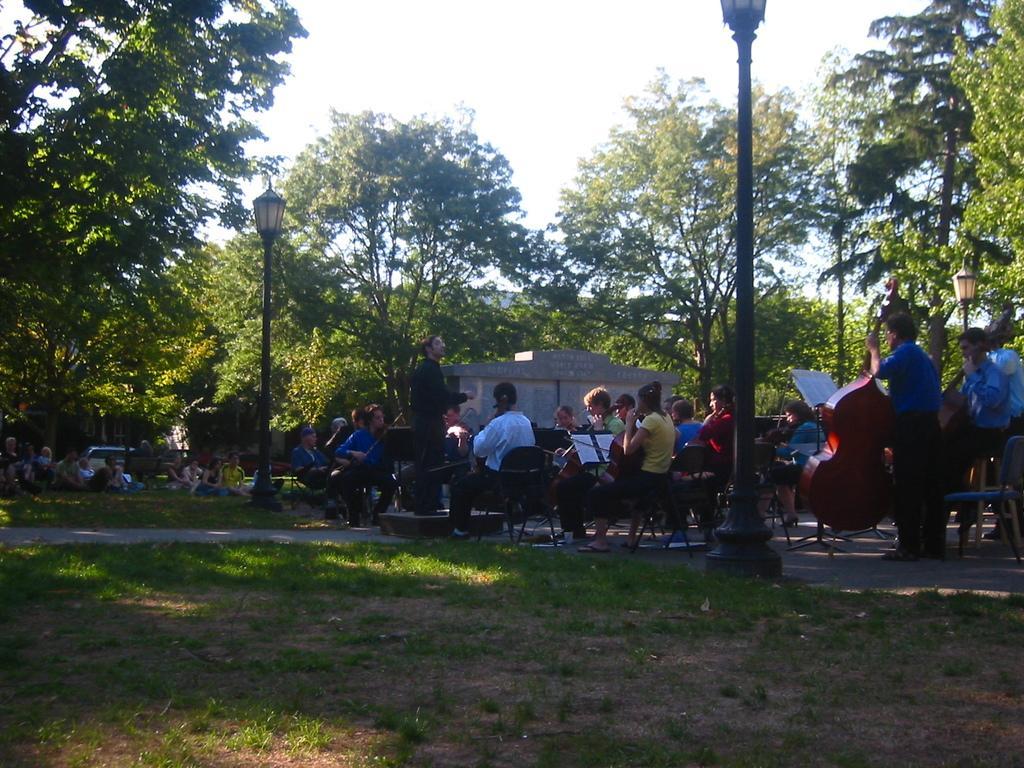Can you describe this image briefly? In this image I see number of people in which most of them are sitting on chairs and rest of them are standing and I can also see most of them are holding musical instruments in their hands and I see the grass and the light poles. In the background I see the trees and the sky and I see a building over here. 